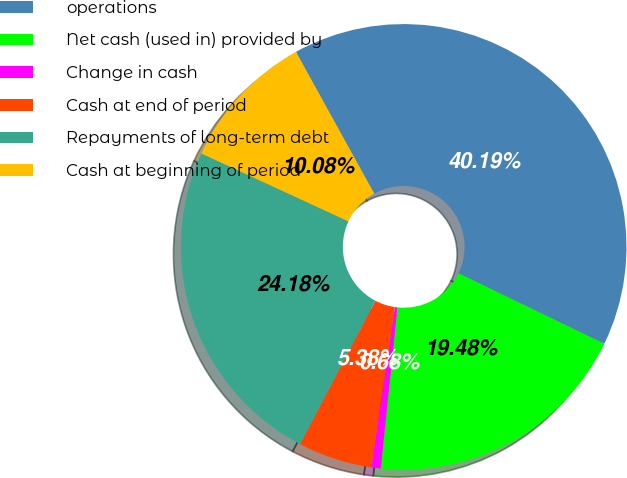Convert chart to OTSL. <chart><loc_0><loc_0><loc_500><loc_500><pie_chart><fcel>operations<fcel>Net cash (used in) provided by<fcel>Change in cash<fcel>Cash at end of period<fcel>Repayments of long-term debt<fcel>Cash at beginning of period<nl><fcel>40.19%<fcel>19.48%<fcel>0.68%<fcel>5.38%<fcel>24.18%<fcel>10.08%<nl></chart> 